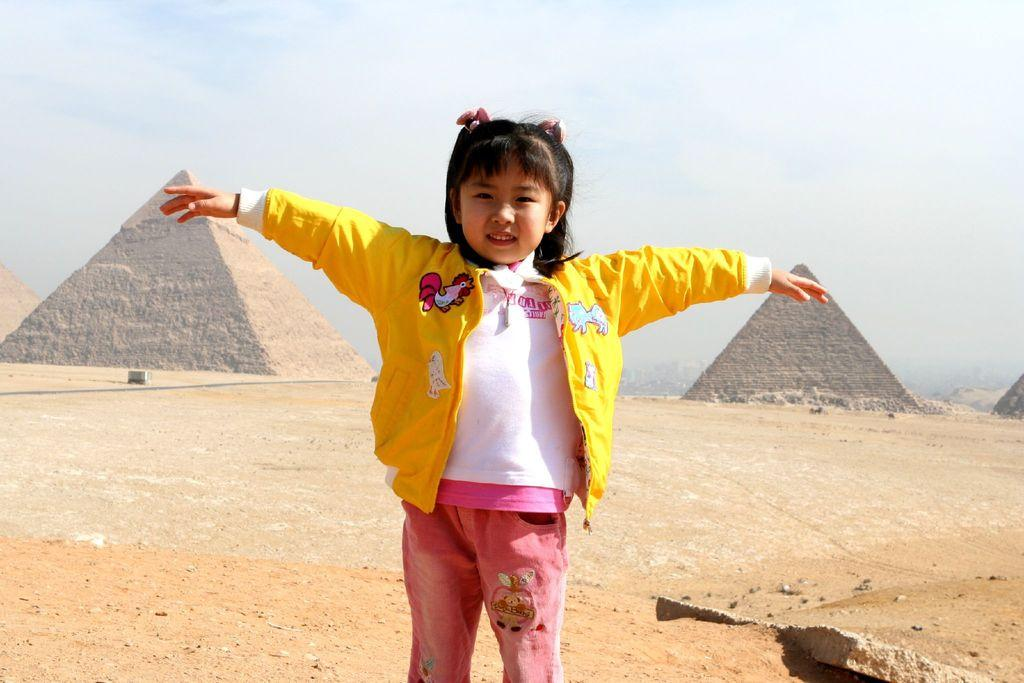What is the main subject of the image? There is a person in the image. What is the person wearing? The person is wearing a yellow jacket, a white shirt, and pink pants. What can be seen in the background of the image? There are pyramids and the sky in the background of the image. How would you describe the color of the sky in the image? The sky has a combination of white and blue colors. What type of fruit is the person holding in the image? There is no fruit present in the image. Is the person using a fork to eat in the image? There is no fork visible in the image, and the person's actions are not described. 